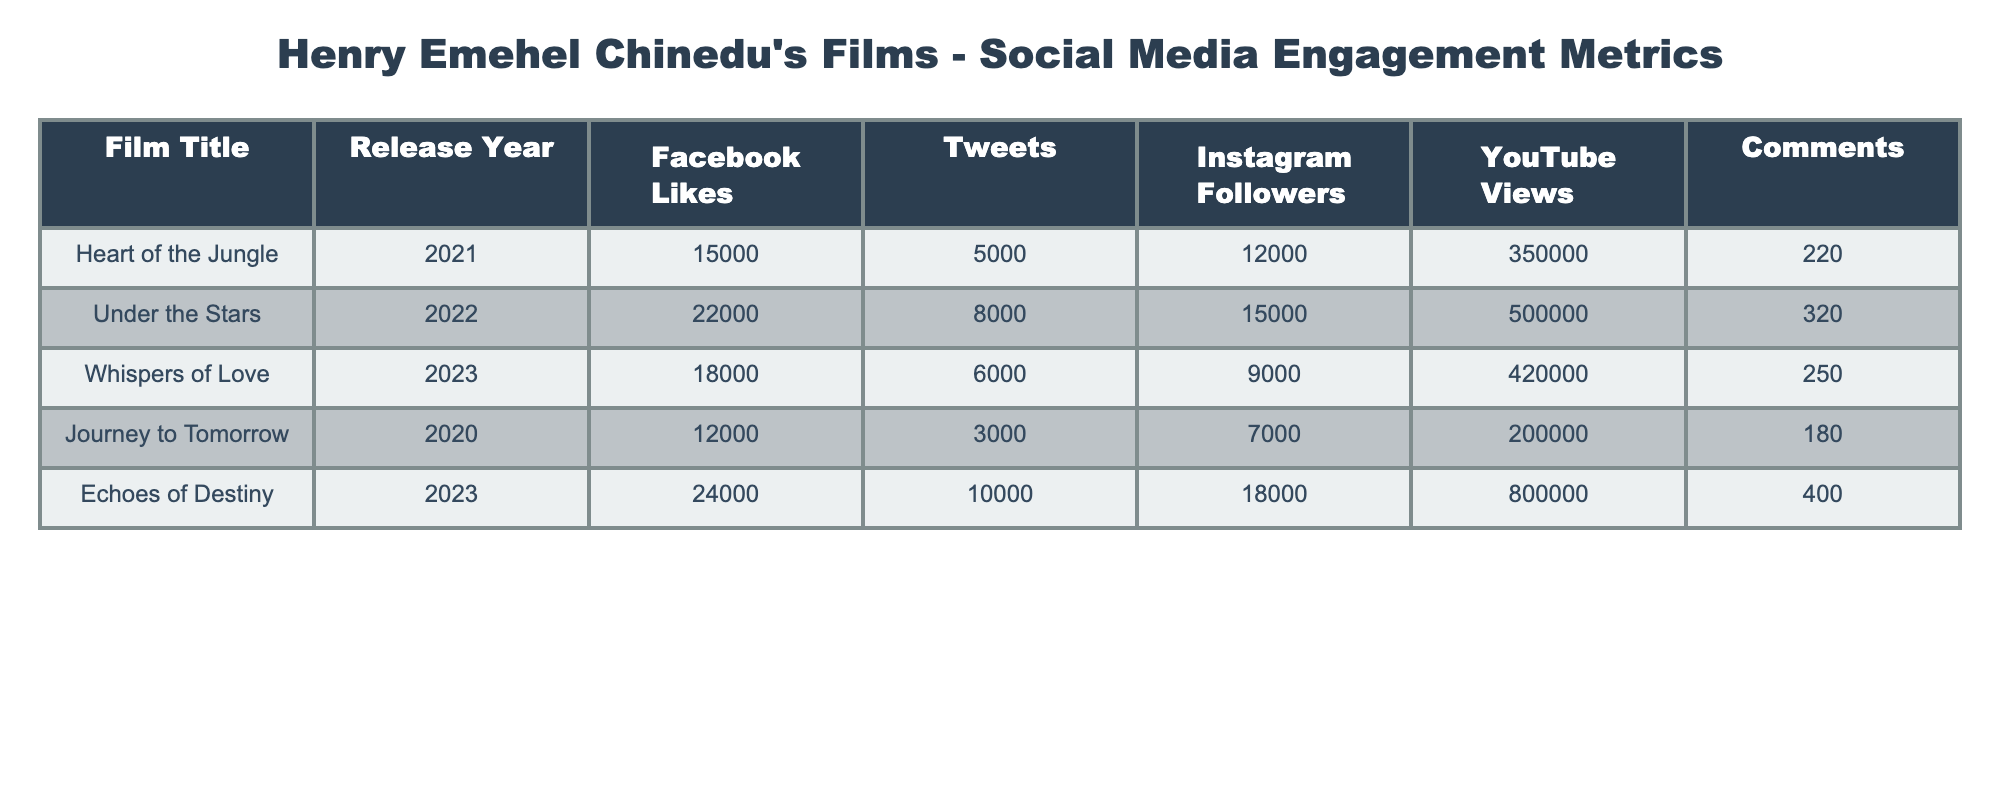What film had the highest number of Facebook Likes? The film "Echoes of Destiny" has the highest number of Facebook Likes with 24000 likes. This is the largest value in the Facebook Likes column.
Answer: Echoes of Destiny What is the total number of Tweets across all films? To find the total number of Tweets, we add the values: 5000 + 8000 + 6000 + 3000 + 10000 = 35000. Therefore, the total number of Tweets is 35000.
Answer: 35000 Which film had the most YouTube Views in 2023? In 2023, "Echoes of Destiny" had 800000 YouTube Views, which is the highest compared to "Whispers of Love" that had 420000 views. Thus, the answer is "Echoes of Destiny".
Answer: Echoes of Destiny Are there more Instagram Followers for "Heart of the Jungle" than for "Journey to Tomorrow"? "Heart of the Jungle" has 12000 Instagram Followers and "Journey to Tomorrow" has 7000. Since 12000 is greater than 7000, the statement is true.
Answer: Yes What is the difference in the number of Comments between "Under the Stars" and "Echoes of Destiny"? To find the difference, we subtract the Comments for "Under the Stars" (320) from "Echoes of Destiny" (400): 400 - 320 = 80. Therefore, the difference is 80.
Answer: 80 What is the average number of Instagram Followers for all films released before 2023? The films released before 2023 are "Heart of the Jungle", "Under the Stars", and "Journey to Tomorrow". The total number of Instagram Followers for these films is 12000 + 15000 + 7000 = 34000. There are 3 films, so the average is 34000 / 3 = 11333.33, rounded to 11333.
Answer: 11333 Did "Journey to Tomorrow" have more YouTube Views than "Heart of the Jungle"? "Journey to Tomorrow" has 200000 YouTube Views while "Heart of the Jungle" has 350000 views. Since 200000 is less than 350000, the statement is false.
Answer: No Which film had the greatest engagement overall based on Comments? To determine overall engagement based on Comments, we compare the values: "Heart of the Jungle" = 220, "Under the Stars" = 320, "Whispers of Love" = 250, "Journey to Tomorrow" = 180, "Echoes of Destiny" = 400. The highest number of Comments is 400 from "Echoes of Destiny". Therefore it had the greatest engagement.
Answer: Echoes of Destiny What is the total of Facebook Likes and Instagram Followers for "Whispers of Love"? For "Whispers of Love", Facebook Likes = 18000 and Instagram Followers = 9000. The total is 18000 + 9000 = 27000.
Answer: 27000 